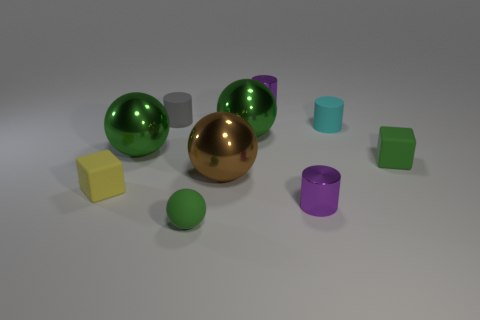Do the tiny gray cylinder and the tiny thing on the left side of the small gray rubber thing have the same material?
Your answer should be very brief. Yes. What shape is the small yellow object that is the same material as the small ball?
Your response must be concise. Cube. The matte cylinder that is the same size as the cyan rubber thing is what color?
Keep it short and to the point. Gray. Is the size of the matte cube to the left of the gray matte cylinder the same as the brown metal sphere?
Make the answer very short. No. How many brown metal balls are there?
Your answer should be compact. 1. How many blocks are either small brown things or tiny green rubber things?
Your response must be concise. 1. How many large green metal balls are on the right side of the green rubber object behind the small matte sphere?
Keep it short and to the point. 0. Is the material of the brown sphere the same as the gray object?
Keep it short and to the point. No. Are there any other small balls that have the same material as the brown ball?
Make the answer very short. No. What is the color of the cylinder that is to the right of the small purple cylinder that is in front of the purple cylinder that is behind the brown ball?
Provide a short and direct response. Cyan. 